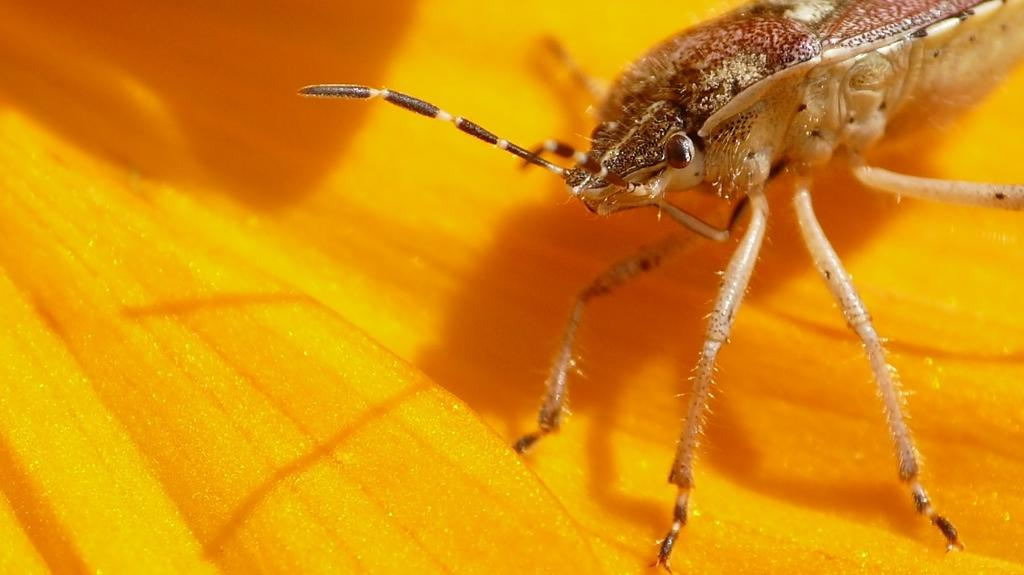What is present on the flower in the image? There is an insect on the flower in the image. Can you describe the insect's location on the flower? The insect is on the flower in the image. What news headline is visible on the insect's face in the image? There is no news headline or face present in the image. 